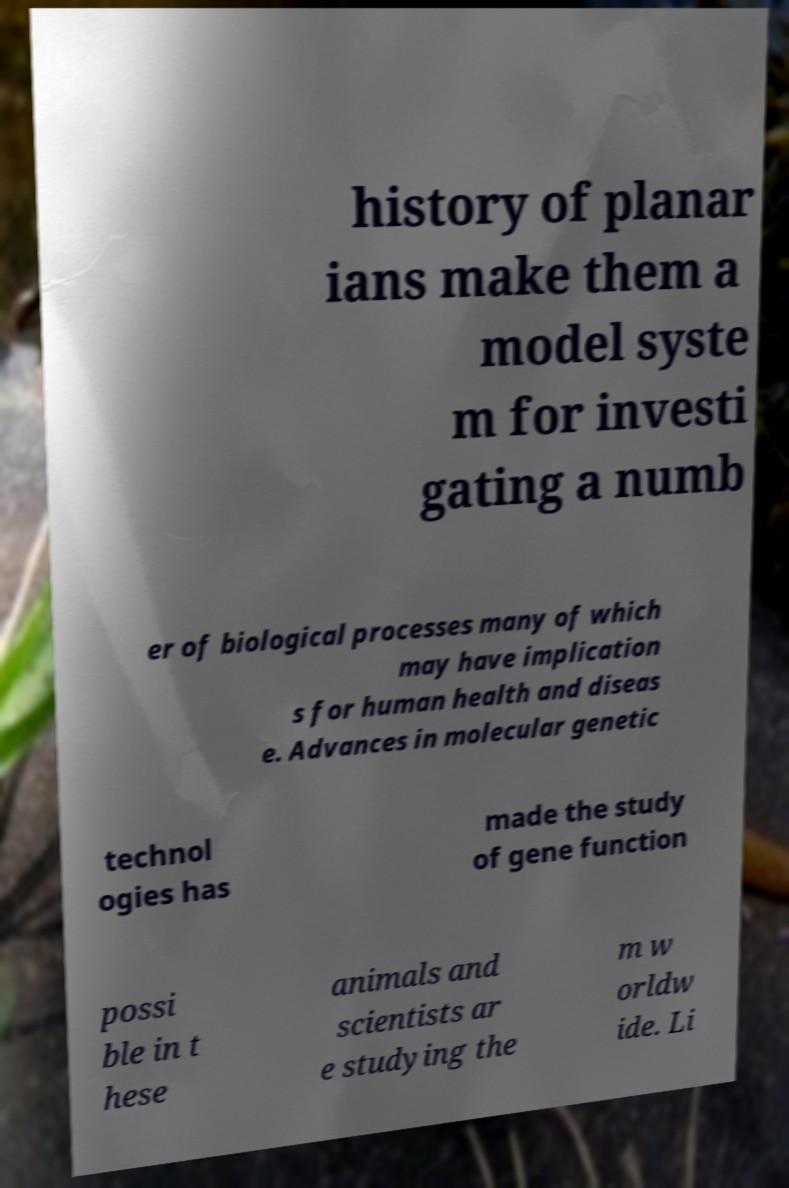Could you extract and type out the text from this image? history of planar ians make them a model syste m for investi gating a numb er of biological processes many of which may have implication s for human health and diseas e. Advances in molecular genetic technol ogies has made the study of gene function possi ble in t hese animals and scientists ar e studying the m w orldw ide. Li 